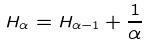<formula> <loc_0><loc_0><loc_500><loc_500>H _ { \alpha } = H _ { \alpha - 1 } + \frac { 1 } { \alpha }</formula> 